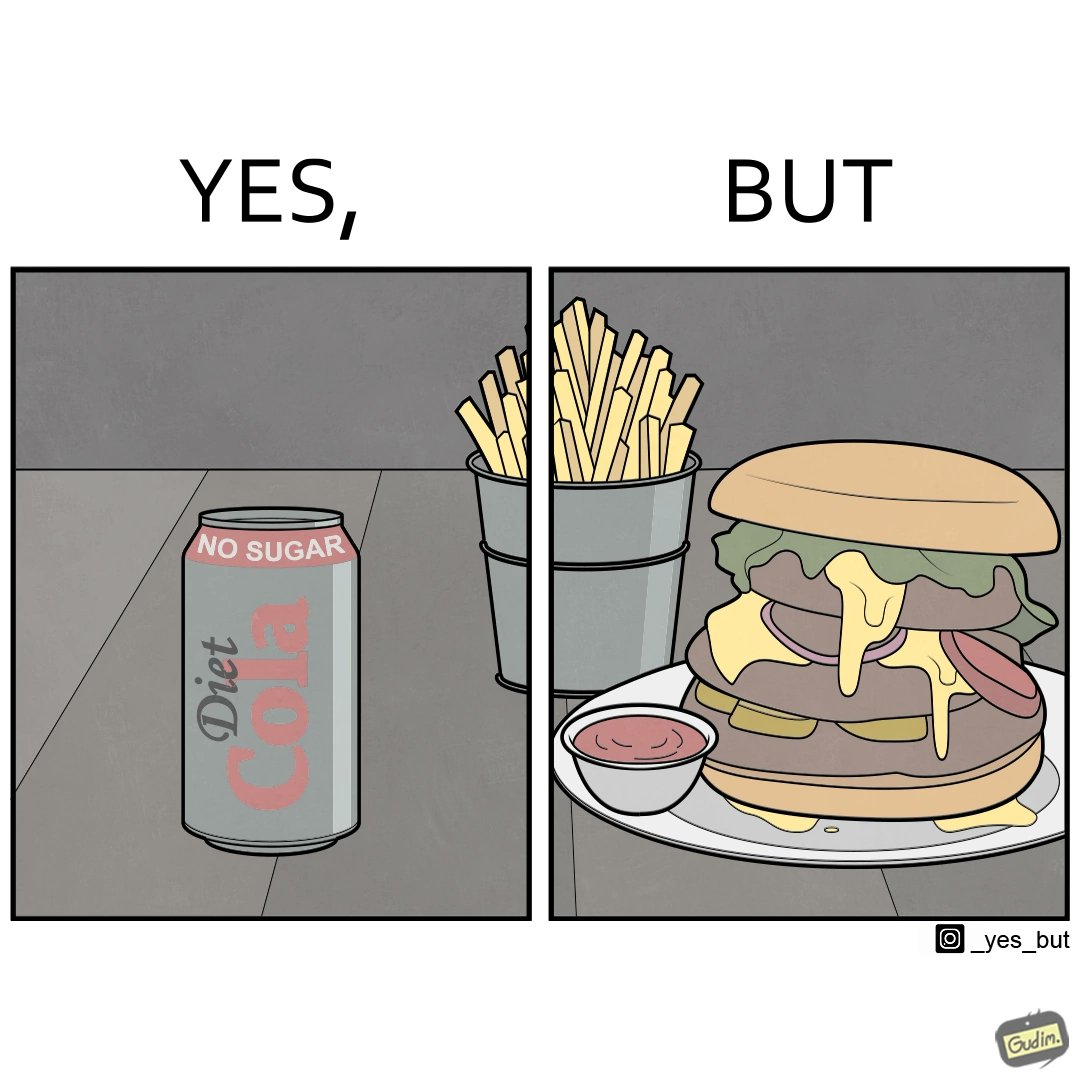Is this image satirical or non-satirical? Yes, this image is satirical. 